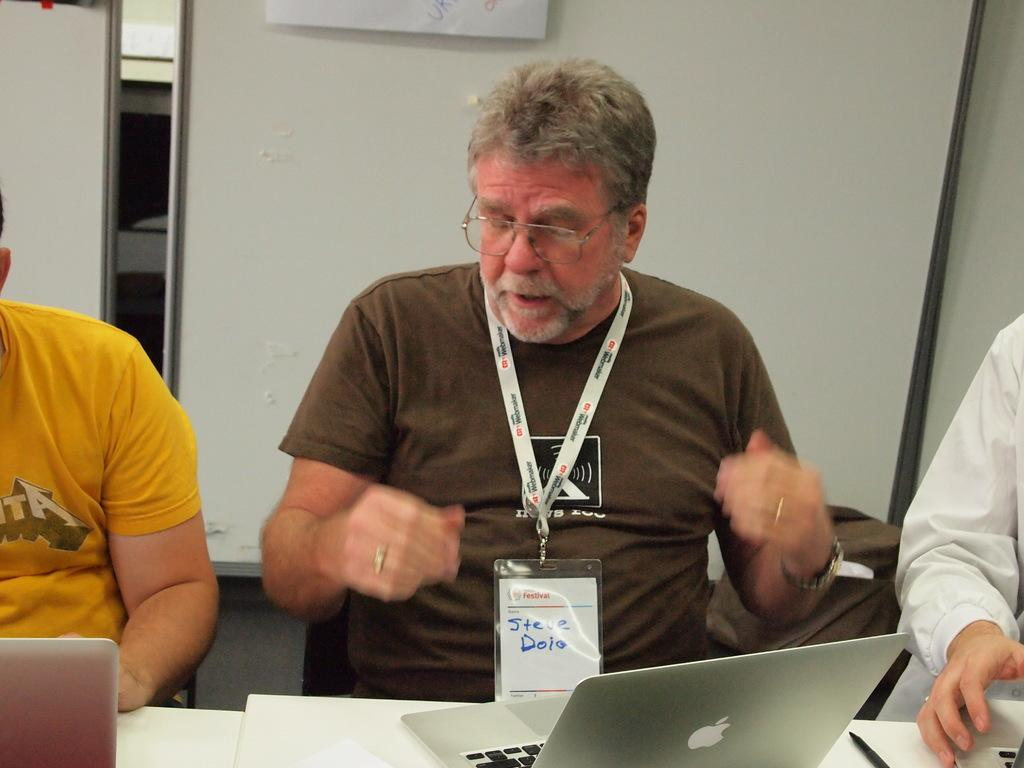How many people are in the image? There are persons in the image, but the exact number is not specified. What are the persons wearing? The persons are wearing clothes. What objects can be seen on the table in the image? There are laptops on a table in the image. What can be seen in the background of the image? There is a board visible in the background of the image. Can you tell me how many boats are in the image? There are no boats present in the image. What type of laughter can be heard coming from the persons in the image? The image does not provide any information about the sounds or expressions of the persons, so it is not possible to determine if they are laughing or what type of laughter might be heard. 